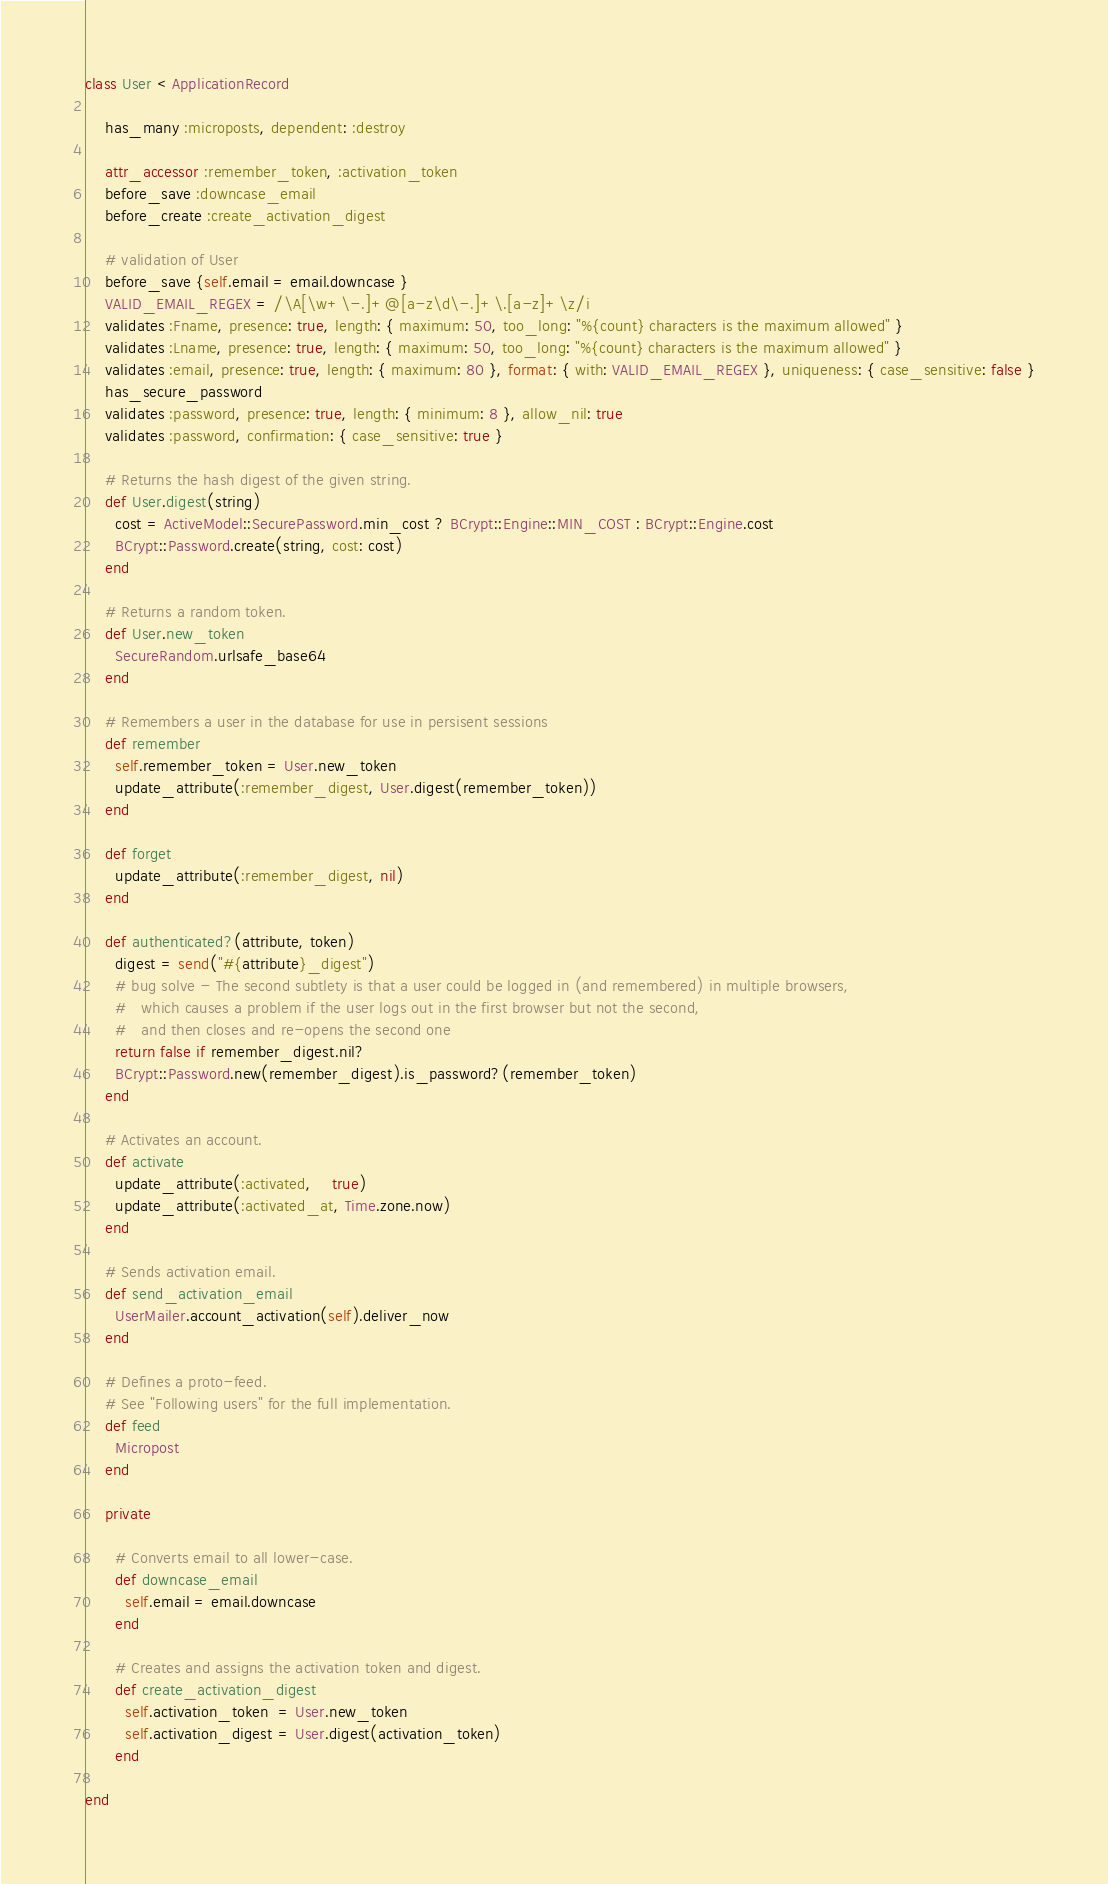<code> <loc_0><loc_0><loc_500><loc_500><_Ruby_>class User < ApplicationRecord

    has_many :microposts, dependent: :destroy

    attr_accessor :remember_token, :activation_token
    before_save :downcase_email
    before_create :create_activation_digest

    # validation of User
    before_save {self.email = email.downcase }
    VALID_EMAIL_REGEX = /\A[\w+\-.]+@[a-z\d\-.]+\.[a-z]+\z/i
    validates :Fname, presence: true, length: { maximum: 50, too_long: "%{count} characters is the maximum allowed" }
    validates :Lname, presence: true, length: { maximum: 50, too_long: "%{count} characters is the maximum allowed" }
    validates :email, presence: true, length: { maximum: 80 }, format: { with: VALID_EMAIL_REGEX }, uniqueness: { case_sensitive: false }
    has_secure_password
    validates :password, presence: true, length: { minimum: 8 }, allow_nil: true
    validates :password, confirmation: { case_sensitive: true }

    # Returns the hash digest of the given string.
    def User.digest(string)
      cost = ActiveModel::SecurePassword.min_cost ? BCrypt::Engine::MIN_COST : BCrypt::Engine.cost
      BCrypt::Password.create(string, cost: cost)
    end

    # Returns a random token.
    def User.new_token
      SecureRandom.urlsafe_base64
    end

    # Remembers a user in the database for use in persisent sessions
    def remember
      self.remember_token = User.new_token
      update_attribute(:remember_digest, User.digest(remember_token))
    end

    def forget
      update_attribute(:remember_digest, nil)
    end

    def authenticated?(attribute, token)
      digest = send("#{attribute}_digest")
      # bug solve - The second subtlety is that a user could be logged in (and remembered) in multiple browsers,
      #   which causes a problem if the user logs out in the first browser but not the second,
      #   and then closes and re-opens the second one
      return false if remember_digest.nil?
      BCrypt::Password.new(remember_digest).is_password?(remember_token)
    end

    # Activates an account.
    def activate
      update_attribute(:activated,    true)
      update_attribute(:activated_at, Time.zone.now)
    end

    # Sends activation email.
    def send_activation_email
      UserMailer.account_activation(self).deliver_now
    end

    # Defines a proto-feed.
    # See "Following users" for the full implementation.
    def feed
      Micropost
    end

    private

      # Converts email to all lower-case.
      def downcase_email
        self.email = email.downcase
      end
  
      # Creates and assigns the activation token and digest.
      def create_activation_digest
        self.activation_token  = User.new_token
        self.activation_digest = User.digest(activation_token)
      end

end
</code> 